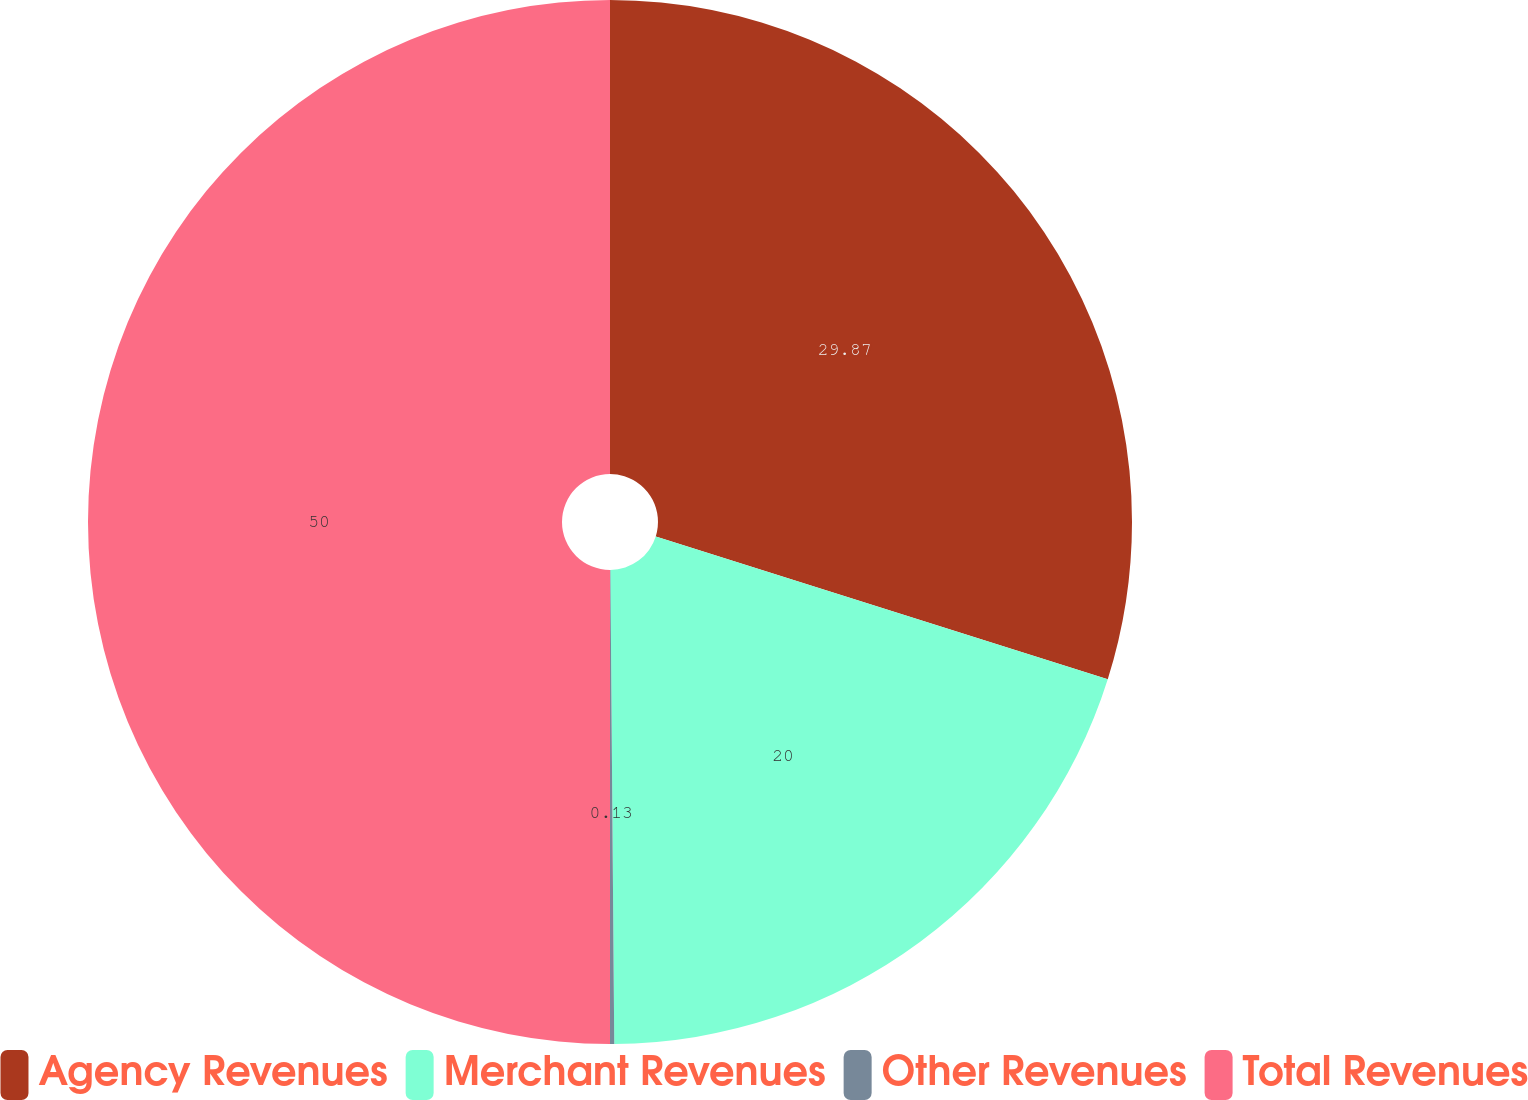Convert chart. <chart><loc_0><loc_0><loc_500><loc_500><pie_chart><fcel>Agency Revenues<fcel>Merchant Revenues<fcel>Other Revenues<fcel>Total Revenues<nl><fcel>29.87%<fcel>20.0%<fcel>0.13%<fcel>50.0%<nl></chart> 